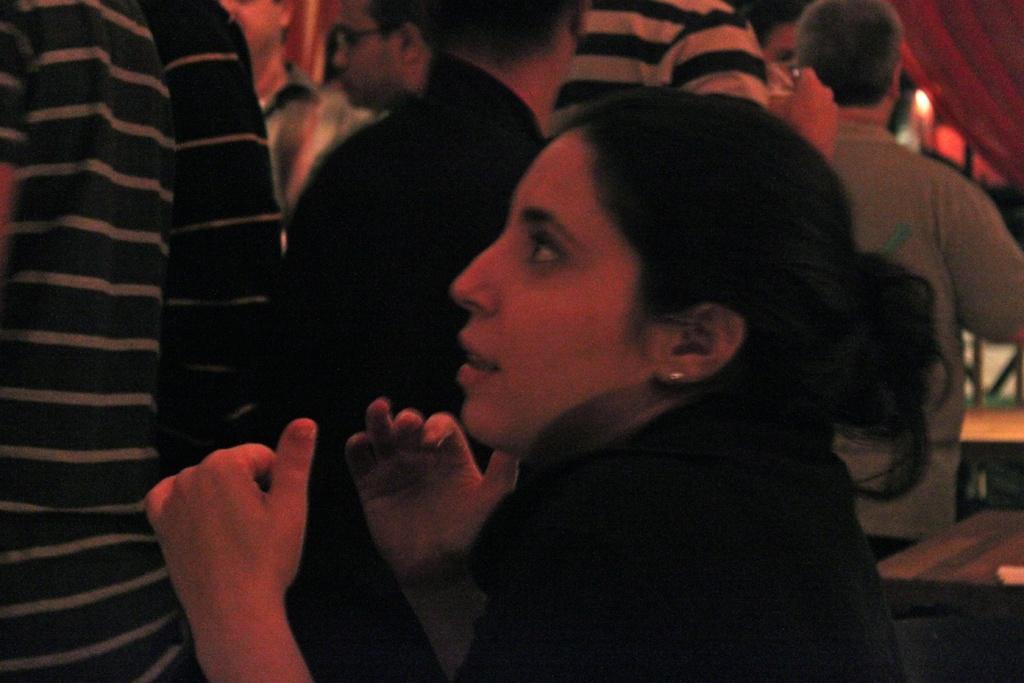How would you summarize this image in a sentence or two? In the background we can see people. In this picture we can see a woman. On the right side of the picture we can see objects and a light is visible. 